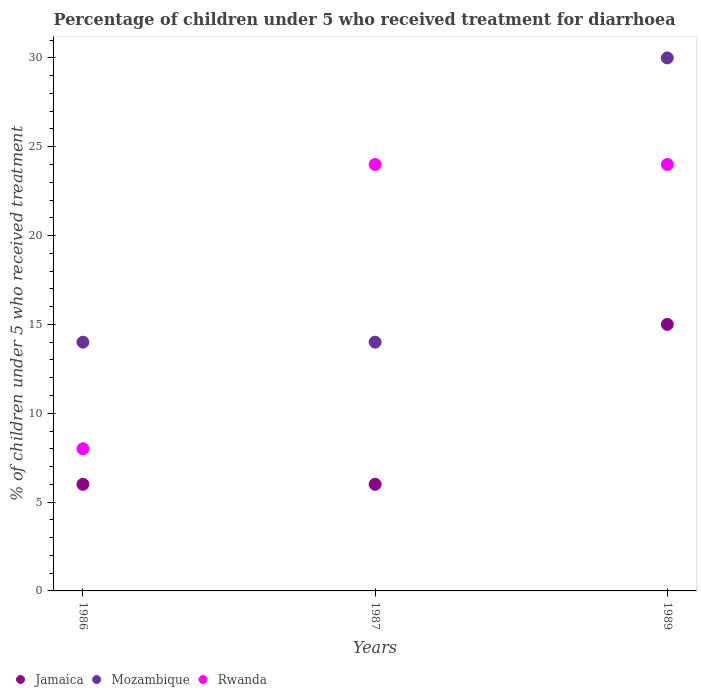How many different coloured dotlines are there?
Keep it short and to the point. 3. Across all years, what is the minimum percentage of children who received treatment for diarrhoea  in Rwanda?
Provide a succinct answer. 8. What is the total percentage of children who received treatment for diarrhoea  in Jamaica in the graph?
Provide a short and direct response. 27. What is the average percentage of children who received treatment for diarrhoea  in Jamaica per year?
Your response must be concise. 9. In how many years, is the percentage of children who received treatment for diarrhoea  in Rwanda greater than 4 %?
Your response must be concise. 3. What is the difference between the highest and the lowest percentage of children who received treatment for diarrhoea  in Jamaica?
Your answer should be very brief. 9. Is it the case that in every year, the sum of the percentage of children who received treatment for diarrhoea  in Jamaica and percentage of children who received treatment for diarrhoea  in Mozambique  is greater than the percentage of children who received treatment for diarrhoea  in Rwanda?
Offer a terse response. No. Does the percentage of children who received treatment for diarrhoea  in Rwanda monotonically increase over the years?
Keep it short and to the point. No. Is the percentage of children who received treatment for diarrhoea  in Rwanda strictly greater than the percentage of children who received treatment for diarrhoea  in Mozambique over the years?
Provide a succinct answer. No. How many years are there in the graph?
Keep it short and to the point. 3. What is the difference between two consecutive major ticks on the Y-axis?
Provide a short and direct response. 5. Are the values on the major ticks of Y-axis written in scientific E-notation?
Keep it short and to the point. No. Does the graph contain any zero values?
Make the answer very short. No. Where does the legend appear in the graph?
Provide a short and direct response. Bottom left. How are the legend labels stacked?
Offer a terse response. Horizontal. What is the title of the graph?
Offer a terse response. Percentage of children under 5 who received treatment for diarrhoea. What is the label or title of the Y-axis?
Your response must be concise. % of children under 5 who received treatment. What is the % of children under 5 who received treatment in Mozambique in 1986?
Offer a very short reply. 14. What is the % of children under 5 who received treatment of Jamaica in 1987?
Your response must be concise. 6. What is the % of children under 5 who received treatment of Mozambique in 1987?
Make the answer very short. 14. What is the % of children under 5 who received treatment of Mozambique in 1989?
Provide a short and direct response. 30. Across all years, what is the maximum % of children under 5 who received treatment in Mozambique?
Ensure brevity in your answer.  30. Across all years, what is the minimum % of children under 5 who received treatment in Mozambique?
Your answer should be compact. 14. What is the total % of children under 5 who received treatment in Mozambique in the graph?
Provide a succinct answer. 58. What is the total % of children under 5 who received treatment in Rwanda in the graph?
Provide a short and direct response. 56. What is the difference between the % of children under 5 who received treatment of Jamaica in 1986 and that in 1987?
Provide a short and direct response. 0. What is the difference between the % of children under 5 who received treatment of Mozambique in 1986 and that in 1989?
Your answer should be very brief. -16. What is the difference between the % of children under 5 who received treatment of Rwanda in 1986 and that in 1989?
Your answer should be compact. -16. What is the difference between the % of children under 5 who received treatment in Rwanda in 1987 and that in 1989?
Ensure brevity in your answer.  0. What is the difference between the % of children under 5 who received treatment in Jamaica in 1986 and the % of children under 5 who received treatment in Mozambique in 1987?
Your answer should be very brief. -8. What is the difference between the % of children under 5 who received treatment in Jamaica in 1986 and the % of children under 5 who received treatment in Rwanda in 1987?
Provide a succinct answer. -18. What is the difference between the % of children under 5 who received treatment of Mozambique in 1986 and the % of children under 5 who received treatment of Rwanda in 1987?
Keep it short and to the point. -10. What is the difference between the % of children under 5 who received treatment of Jamaica in 1986 and the % of children under 5 who received treatment of Mozambique in 1989?
Your response must be concise. -24. What is the difference between the % of children under 5 who received treatment of Jamaica in 1987 and the % of children under 5 who received treatment of Rwanda in 1989?
Ensure brevity in your answer.  -18. What is the difference between the % of children under 5 who received treatment of Mozambique in 1987 and the % of children under 5 who received treatment of Rwanda in 1989?
Ensure brevity in your answer.  -10. What is the average % of children under 5 who received treatment in Jamaica per year?
Make the answer very short. 9. What is the average % of children under 5 who received treatment in Mozambique per year?
Provide a short and direct response. 19.33. What is the average % of children under 5 who received treatment of Rwanda per year?
Offer a very short reply. 18.67. In the year 1986, what is the difference between the % of children under 5 who received treatment in Jamaica and % of children under 5 who received treatment in Rwanda?
Offer a very short reply. -2. In the year 1989, what is the difference between the % of children under 5 who received treatment in Jamaica and % of children under 5 who received treatment in Rwanda?
Give a very brief answer. -9. In the year 1989, what is the difference between the % of children under 5 who received treatment in Mozambique and % of children under 5 who received treatment in Rwanda?
Provide a short and direct response. 6. What is the ratio of the % of children under 5 who received treatment in Jamaica in 1986 to that in 1987?
Offer a very short reply. 1. What is the ratio of the % of children under 5 who received treatment of Jamaica in 1986 to that in 1989?
Make the answer very short. 0.4. What is the ratio of the % of children under 5 who received treatment in Mozambique in 1986 to that in 1989?
Your answer should be very brief. 0.47. What is the ratio of the % of children under 5 who received treatment of Rwanda in 1986 to that in 1989?
Make the answer very short. 0.33. What is the ratio of the % of children under 5 who received treatment in Jamaica in 1987 to that in 1989?
Keep it short and to the point. 0.4. What is the ratio of the % of children under 5 who received treatment in Mozambique in 1987 to that in 1989?
Offer a terse response. 0.47. What is the ratio of the % of children under 5 who received treatment in Rwanda in 1987 to that in 1989?
Provide a short and direct response. 1. What is the difference between the highest and the second highest % of children under 5 who received treatment of Jamaica?
Offer a very short reply. 9. What is the difference between the highest and the second highest % of children under 5 who received treatment in Mozambique?
Your answer should be compact. 16. What is the difference between the highest and the lowest % of children under 5 who received treatment in Jamaica?
Offer a terse response. 9. What is the difference between the highest and the lowest % of children under 5 who received treatment of Mozambique?
Your answer should be very brief. 16. 